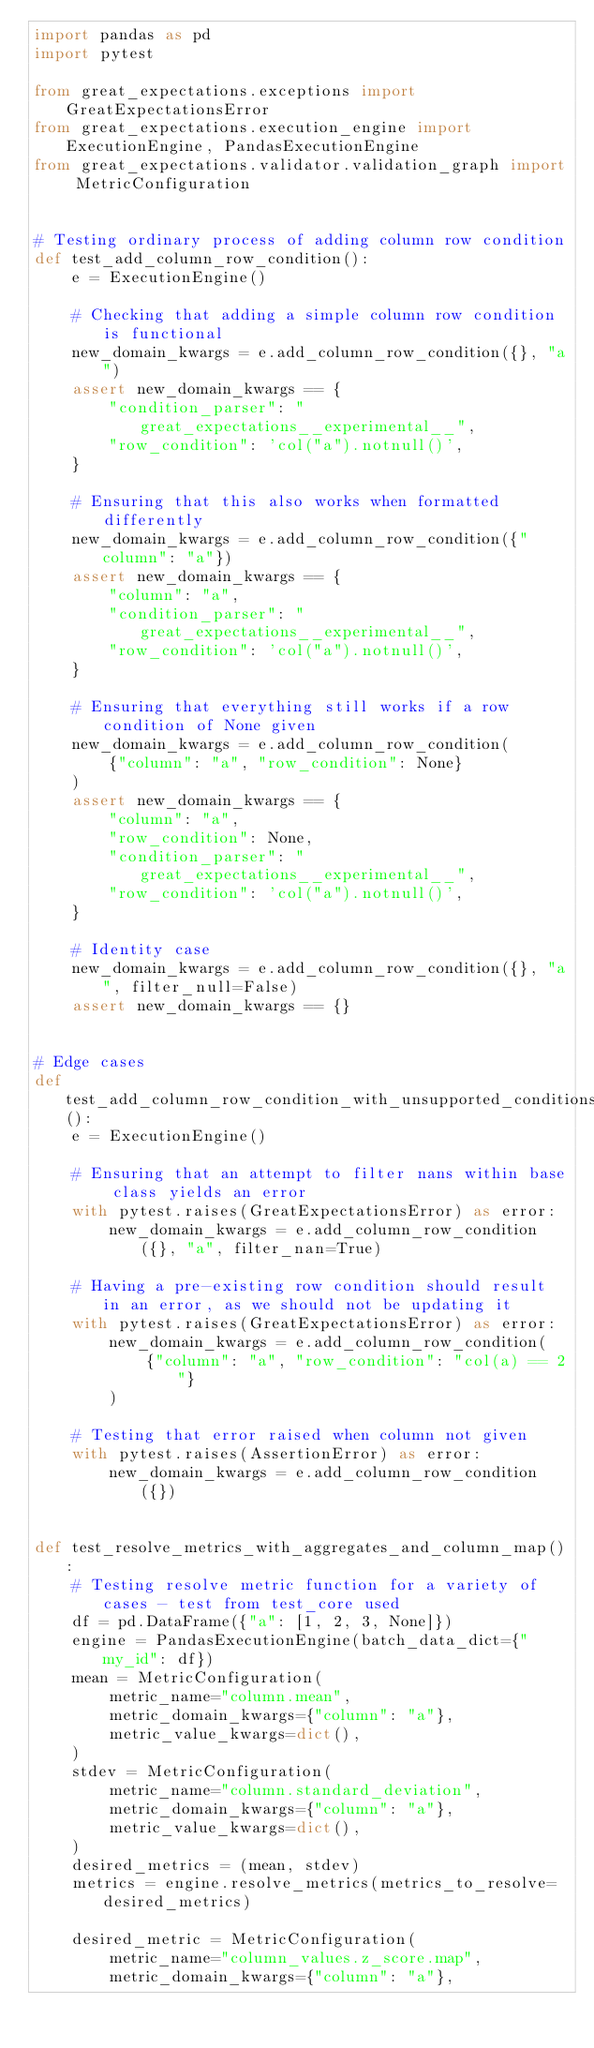<code> <loc_0><loc_0><loc_500><loc_500><_Python_>import pandas as pd
import pytest

from great_expectations.exceptions import GreatExpectationsError
from great_expectations.execution_engine import ExecutionEngine, PandasExecutionEngine
from great_expectations.validator.validation_graph import MetricConfiguration


# Testing ordinary process of adding column row condition
def test_add_column_row_condition():
    e = ExecutionEngine()

    # Checking that adding a simple column row condition is functional
    new_domain_kwargs = e.add_column_row_condition({}, "a")
    assert new_domain_kwargs == {
        "condition_parser": "great_expectations__experimental__",
        "row_condition": 'col("a").notnull()',
    }

    # Ensuring that this also works when formatted differently
    new_domain_kwargs = e.add_column_row_condition({"column": "a"})
    assert new_domain_kwargs == {
        "column": "a",
        "condition_parser": "great_expectations__experimental__",
        "row_condition": 'col("a").notnull()',
    }

    # Ensuring that everything still works if a row condition of None given
    new_domain_kwargs = e.add_column_row_condition(
        {"column": "a", "row_condition": None}
    )
    assert new_domain_kwargs == {
        "column": "a",
        "row_condition": None,
        "condition_parser": "great_expectations__experimental__",
        "row_condition": 'col("a").notnull()',
    }

    # Identity case
    new_domain_kwargs = e.add_column_row_condition({}, "a", filter_null=False)
    assert new_domain_kwargs == {}


# Edge cases
def test_add_column_row_condition_with_unsupported_conditions():
    e = ExecutionEngine()

    # Ensuring that an attempt to filter nans within base class yields an error
    with pytest.raises(GreatExpectationsError) as error:
        new_domain_kwargs = e.add_column_row_condition({}, "a", filter_nan=True)

    # Having a pre-existing row condition should result in an error, as we should not be updating it
    with pytest.raises(GreatExpectationsError) as error:
        new_domain_kwargs = e.add_column_row_condition(
            {"column": "a", "row_condition": "col(a) == 2"}
        )

    # Testing that error raised when column not given
    with pytest.raises(AssertionError) as error:
        new_domain_kwargs = e.add_column_row_condition({})


def test_resolve_metrics_with_aggregates_and_column_map():
    # Testing resolve metric function for a variety of cases - test from test_core used
    df = pd.DataFrame({"a": [1, 2, 3, None]})
    engine = PandasExecutionEngine(batch_data_dict={"my_id": df})
    mean = MetricConfiguration(
        metric_name="column.mean",
        metric_domain_kwargs={"column": "a"},
        metric_value_kwargs=dict(),
    )
    stdev = MetricConfiguration(
        metric_name="column.standard_deviation",
        metric_domain_kwargs={"column": "a"},
        metric_value_kwargs=dict(),
    )
    desired_metrics = (mean, stdev)
    metrics = engine.resolve_metrics(metrics_to_resolve=desired_metrics)

    desired_metric = MetricConfiguration(
        metric_name="column_values.z_score.map",
        metric_domain_kwargs={"column": "a"},</code> 